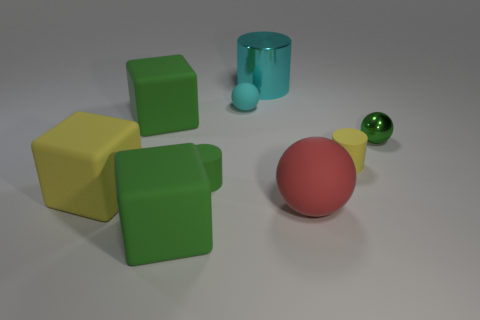Subtract all brown cylinders. Subtract all green balls. How many cylinders are left? 3 Add 1 cubes. How many objects exist? 10 Subtract all cylinders. How many objects are left? 6 Subtract all gray balls. Subtract all rubber cylinders. How many objects are left? 7 Add 7 cyan metallic things. How many cyan metallic things are left? 8 Add 3 large gray blocks. How many large gray blocks exist? 3 Subtract 1 cyan balls. How many objects are left? 8 